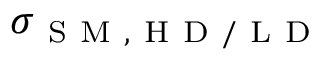Convert formula to latex. <formula><loc_0><loc_0><loc_500><loc_500>\sigma _ { S M , H D / L D }</formula> 